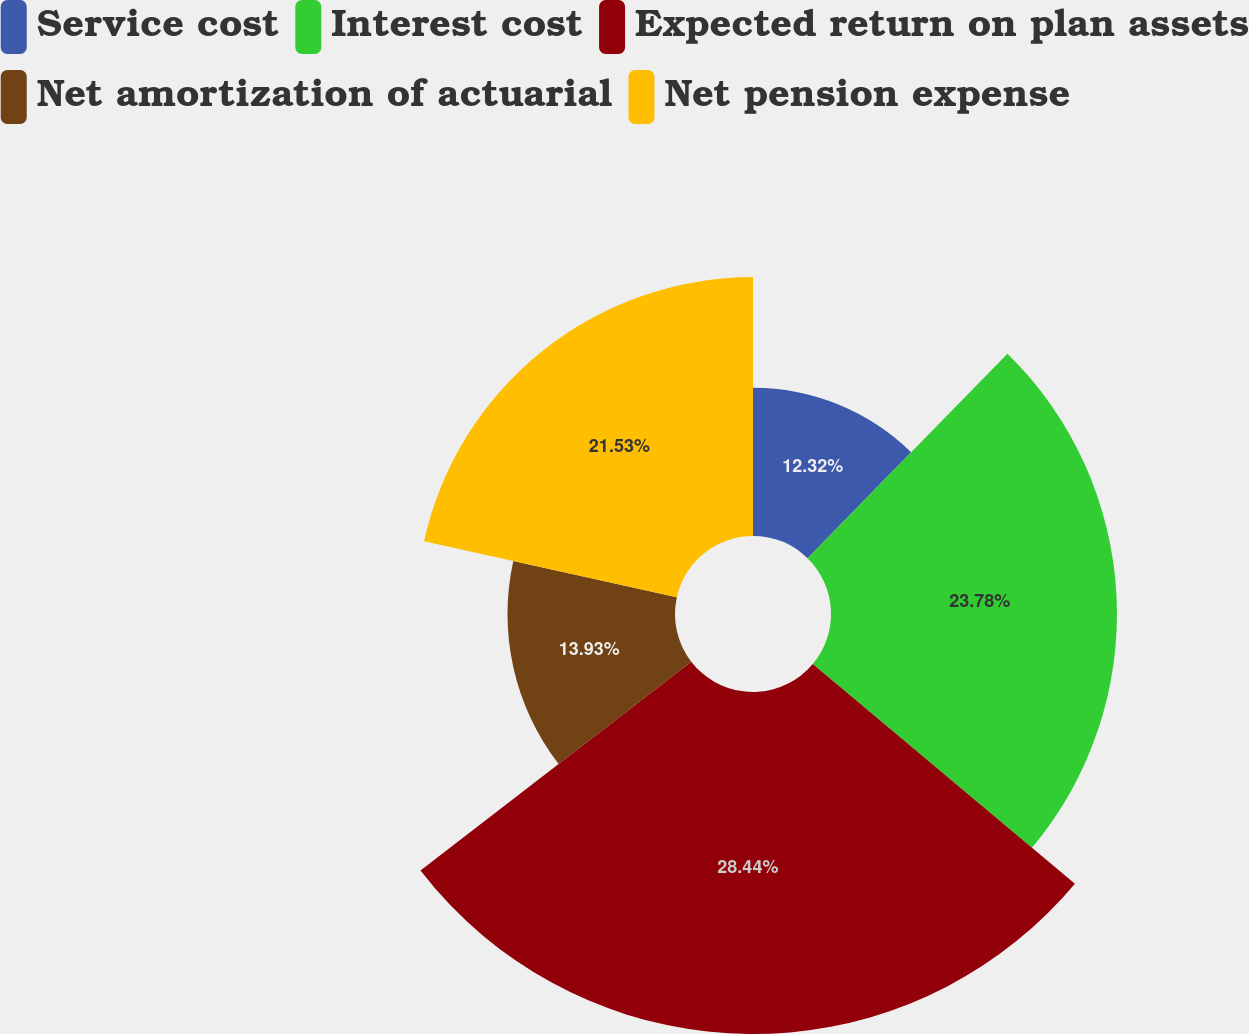Convert chart. <chart><loc_0><loc_0><loc_500><loc_500><pie_chart><fcel>Service cost<fcel>Interest cost<fcel>Expected return on plan assets<fcel>Net amortization of actuarial<fcel>Net pension expense<nl><fcel>12.32%<fcel>23.78%<fcel>28.44%<fcel>13.93%<fcel>21.53%<nl></chart> 